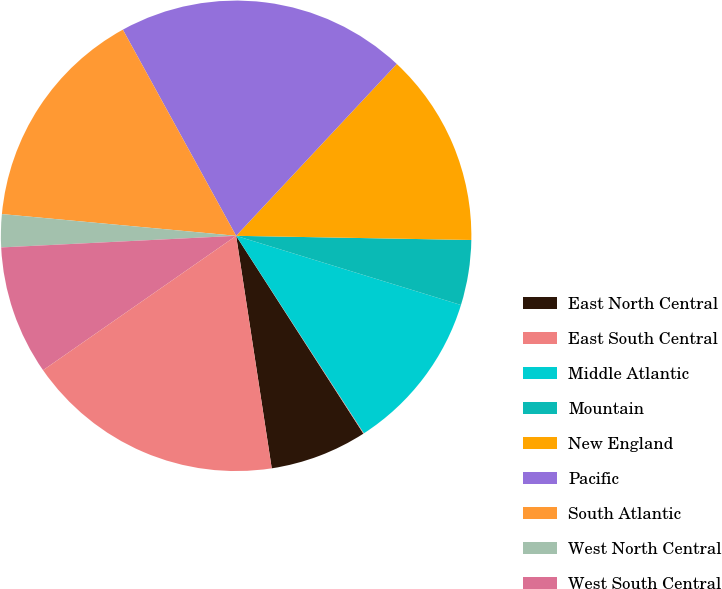<chart> <loc_0><loc_0><loc_500><loc_500><pie_chart><fcel>East North Central<fcel>East South Central<fcel>Middle Atlantic<fcel>Mountain<fcel>New England<fcel>Pacific<fcel>South Atlantic<fcel>West North Central<fcel>West South Central<fcel>Other 1<nl><fcel>6.68%<fcel>0.04%<fcel>11.11%<fcel>4.47%<fcel>13.32%<fcel>19.96%<fcel>15.53%<fcel>2.26%<fcel>8.89%<fcel>17.74%<nl></chart> 